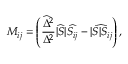Convert formula to latex. <formula><loc_0><loc_0><loc_500><loc_500>M _ { i j } = \left ( { \frac { \widehat { \Delta } ^ { 2 } } { \Delta ^ { 2 } } } \widehat { | S | } \widehat { S _ { i j } } - \widehat { | S | S _ { i j } } \right ) ,</formula> 